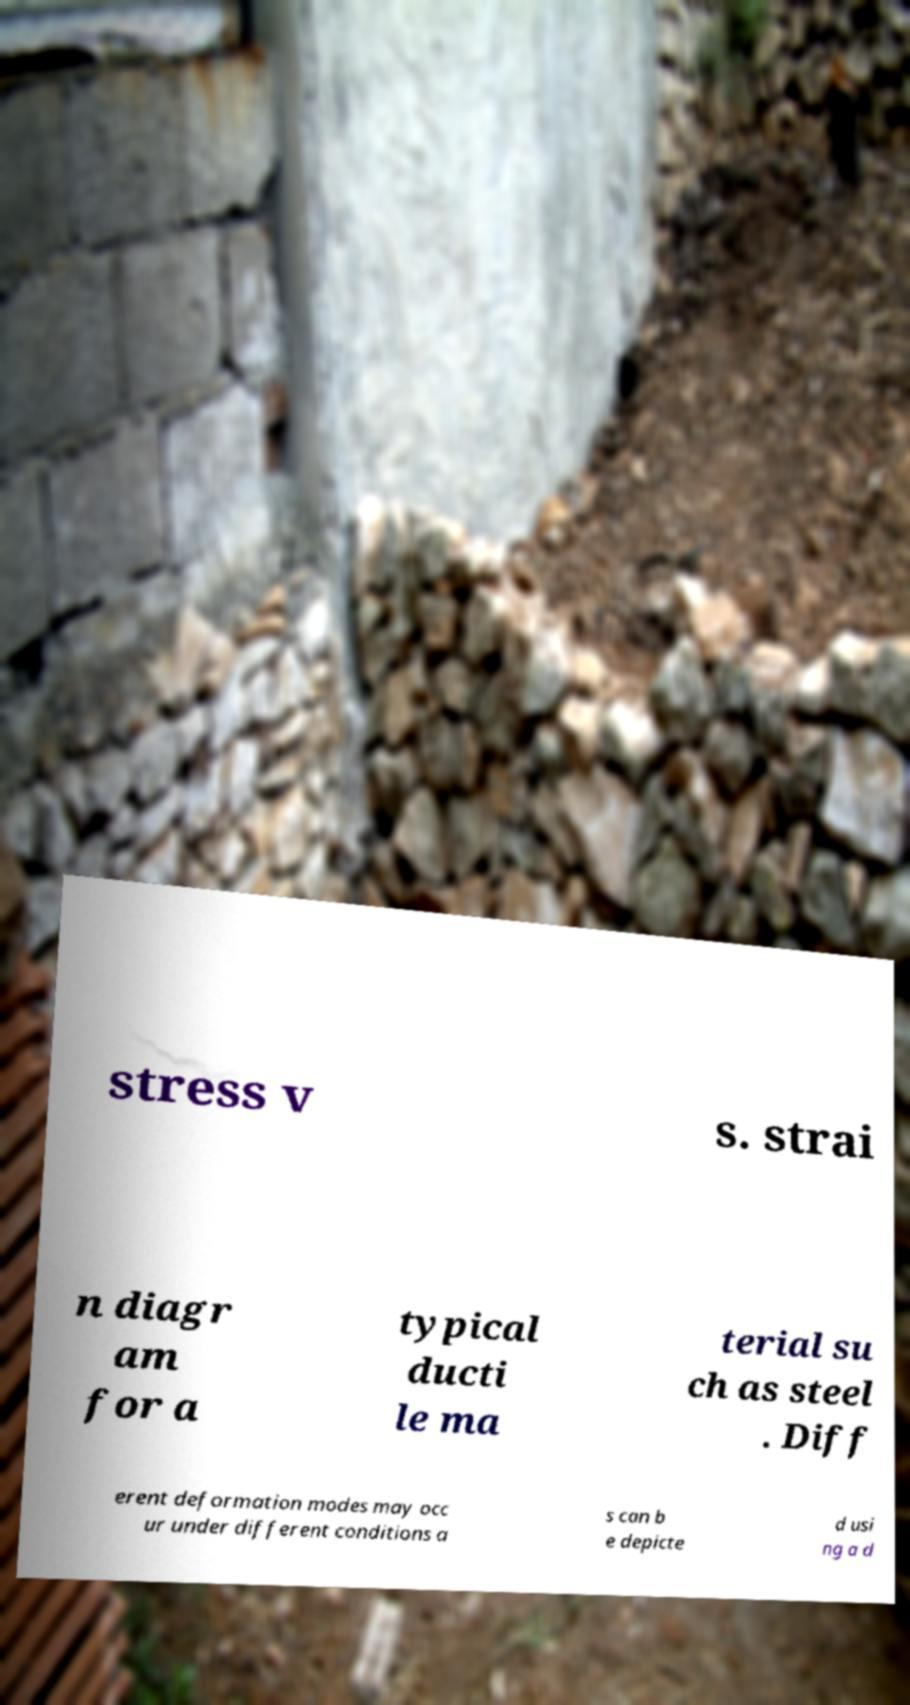For documentation purposes, I need the text within this image transcribed. Could you provide that? stress v s. strai n diagr am for a typical ducti le ma terial su ch as steel . Diff erent deformation modes may occ ur under different conditions a s can b e depicte d usi ng a d 